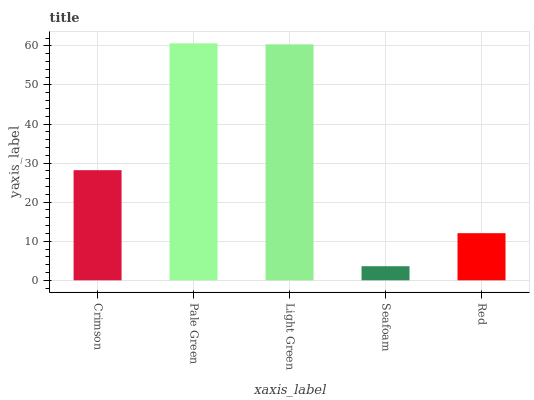Is Seafoam the minimum?
Answer yes or no. Yes. Is Pale Green the maximum?
Answer yes or no. Yes. Is Light Green the minimum?
Answer yes or no. No. Is Light Green the maximum?
Answer yes or no. No. Is Pale Green greater than Light Green?
Answer yes or no. Yes. Is Light Green less than Pale Green?
Answer yes or no. Yes. Is Light Green greater than Pale Green?
Answer yes or no. No. Is Pale Green less than Light Green?
Answer yes or no. No. Is Crimson the high median?
Answer yes or no. Yes. Is Crimson the low median?
Answer yes or no. Yes. Is Red the high median?
Answer yes or no. No. Is Red the low median?
Answer yes or no. No. 